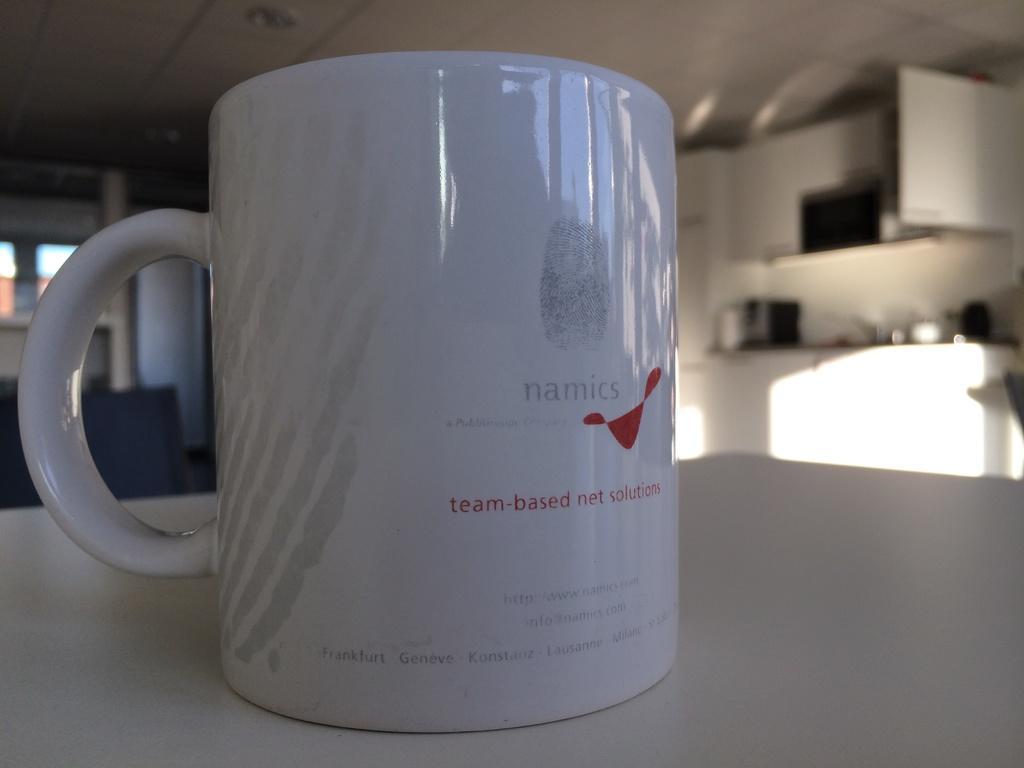Describe this image in one or two sentences. In this image I can see the white color cup on the white surface. Back I can see the windows, white wall and few objects. At the top I can see the ceiling and few lights. 